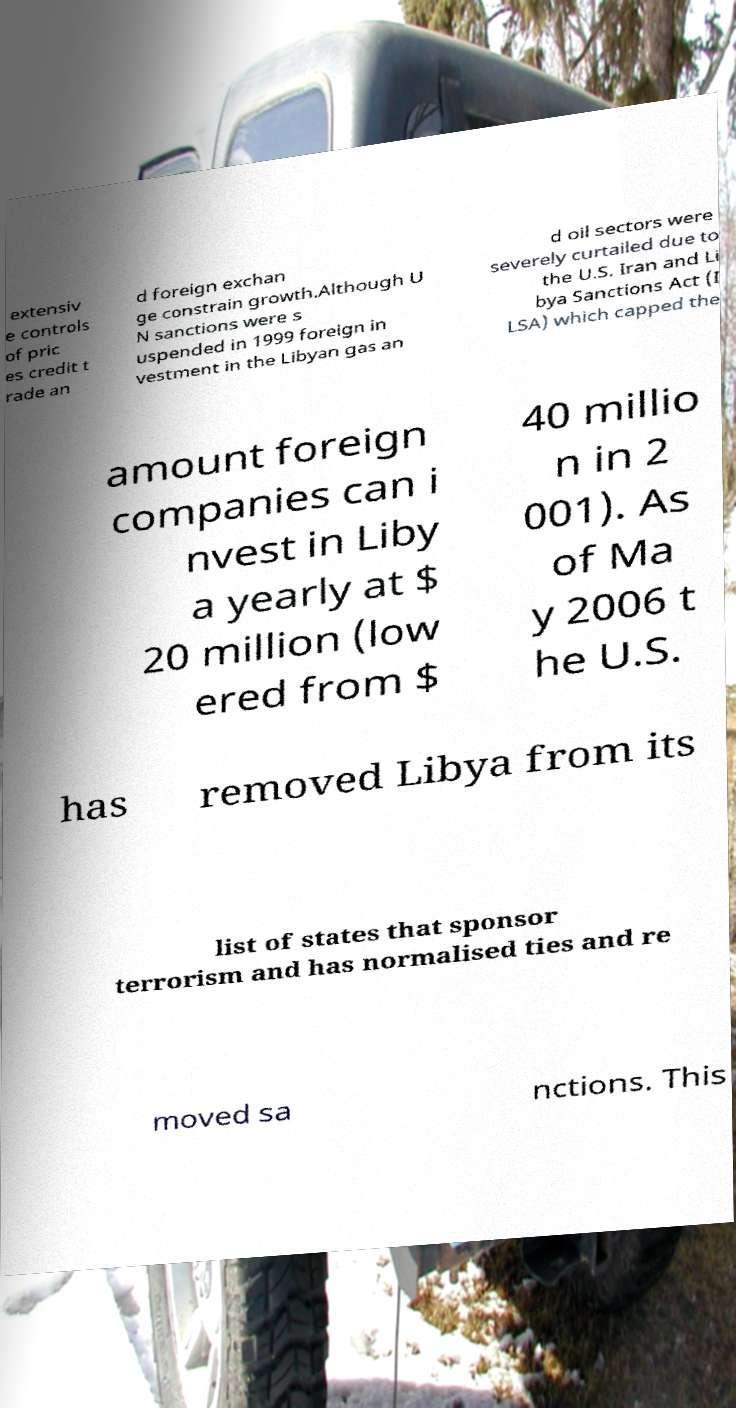Could you assist in decoding the text presented in this image and type it out clearly? extensiv e controls of pric es credit t rade an d foreign exchan ge constrain growth.Although U N sanctions were s uspended in 1999 foreign in vestment in the Libyan gas an d oil sectors were severely curtailed due to the U.S. Iran and Li bya Sanctions Act (I LSA) which capped the amount foreign companies can i nvest in Liby a yearly at $ 20 million (low ered from $ 40 millio n in 2 001). As of Ma y 2006 t he U.S. has removed Libya from its list of states that sponsor terrorism and has normalised ties and re moved sa nctions. This 